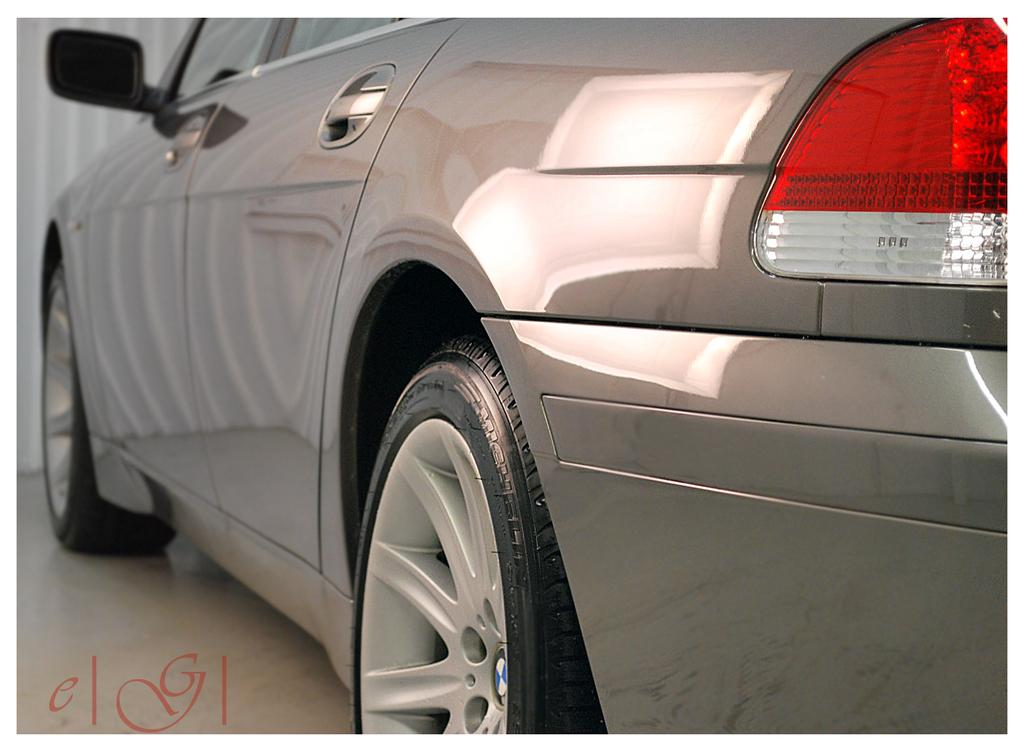What type of vehicle is in the image? There is a gray color vehicle in the image. Where is the vehicle located in the image? The vehicle is parked on the floor and on the right side of the image. What color is the background of the image? The background of the image is white in color. Can you see a monkey climbing on the vehicle in the image? No, there is no monkey present in the image. 